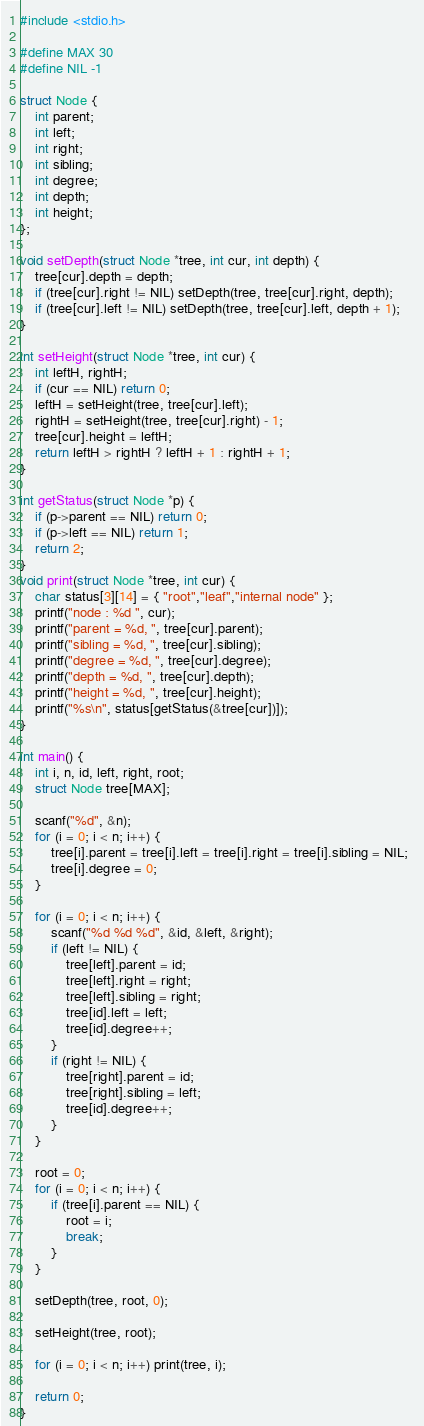Convert code to text. <code><loc_0><loc_0><loc_500><loc_500><_C_>#include <stdio.h>

#define MAX 30
#define NIL -1

struct Node {
	int parent;
	int left;
	int right;
	int sibling;
	int degree;
	int depth;
	int height;
};

void setDepth(struct Node *tree, int cur, int depth) {
	tree[cur].depth = depth;
	if (tree[cur].right != NIL) setDepth(tree, tree[cur].right, depth);
	if (tree[cur].left != NIL) setDepth(tree, tree[cur].left, depth + 1);	
}

int setHeight(struct Node *tree, int cur) {
	int leftH, rightH;
	if (cur == NIL) return 0;
	leftH = setHeight(tree, tree[cur].left);
	rightH = setHeight(tree, tree[cur].right) - 1;
	tree[cur].height = leftH;
	return leftH > rightH ? leftH + 1 : rightH + 1;
}

int getStatus(struct Node *p) {
	if (p->parent == NIL) return 0;
	if (p->left == NIL) return 1;
	return 2;
}
void print(struct Node *tree, int cur) {
	char status[3][14] = { "root","leaf","internal node" };
	printf("node : %d ", cur);
	printf("parent = %d, ", tree[cur].parent);
	printf("sibling = %d, ", tree[cur].sibling);
	printf("degree = %d, ", tree[cur].degree);
	printf("depth = %d, ", tree[cur].depth);
	printf("height = %d, ", tree[cur].height);
	printf("%s\n", status[getStatus(&tree[cur])]);
}

int main() {
	int i, n, id, left, right, root;
	struct Node tree[MAX];

	scanf("%d", &n);
	for (i = 0; i < n; i++) {
		tree[i].parent = tree[i].left = tree[i].right = tree[i].sibling = NIL;
		tree[i].degree = 0;
	}

	for (i = 0; i < n; i++) {
		scanf("%d %d %d", &id, &left, &right);
		if (left != NIL) {
			tree[left].parent = id;
			tree[left].right = right;
			tree[left].sibling = right;
			tree[id].left = left;
			tree[id].degree++;
		}
		if (right != NIL) {
			tree[right].parent = id;
			tree[right].sibling = left;
			tree[id].degree++;
		}
	}

	root = 0;
	for (i = 0; i < n; i++) {
		if (tree[i].parent == NIL) {
			root = i;
			break;
		}
	}

	setDepth(tree, root, 0);

	setHeight(tree, root);

	for (i = 0; i < n; i++) print(tree, i);

	return 0;
}
</code> 